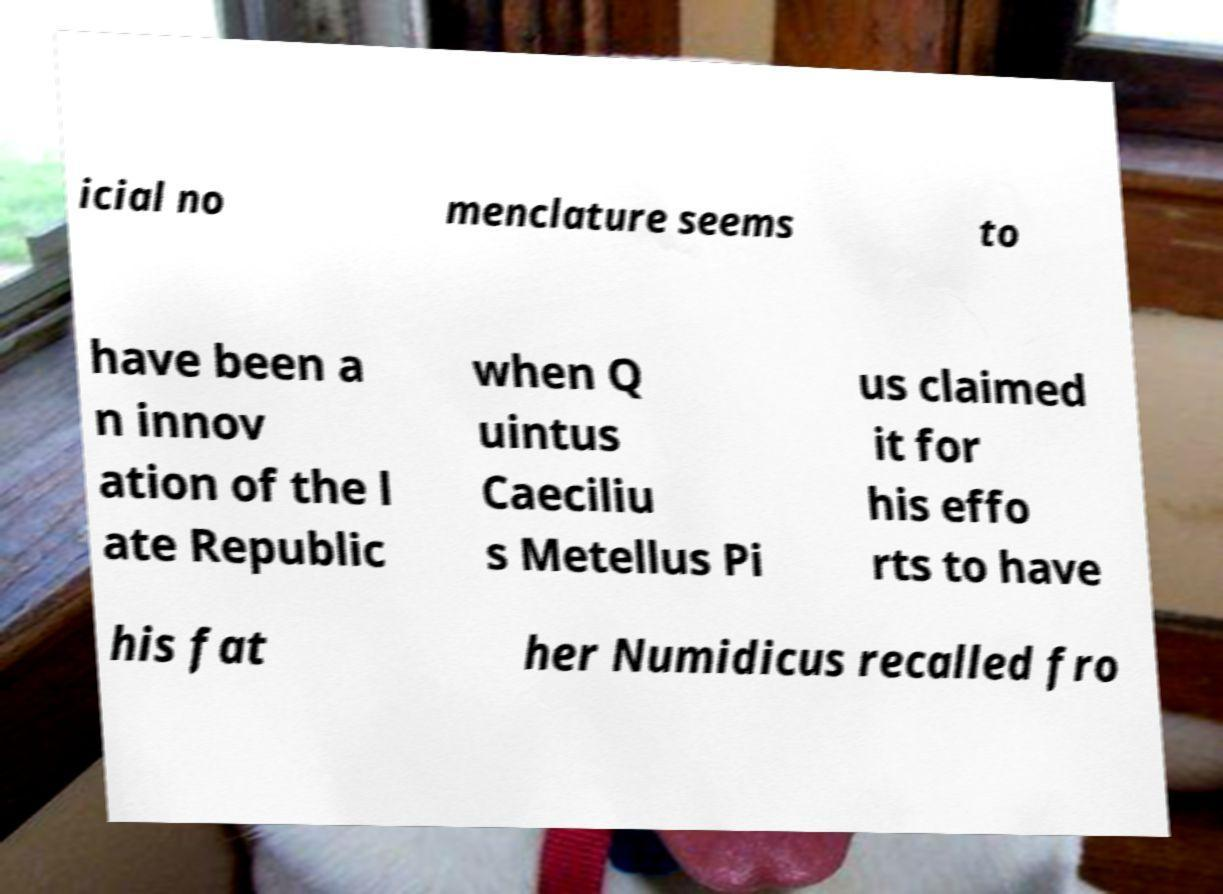Please read and relay the text visible in this image. What does it say? icial no menclature seems to have been a n innov ation of the l ate Republic when Q uintus Caeciliu s Metellus Pi us claimed it for his effo rts to have his fat her Numidicus recalled fro 